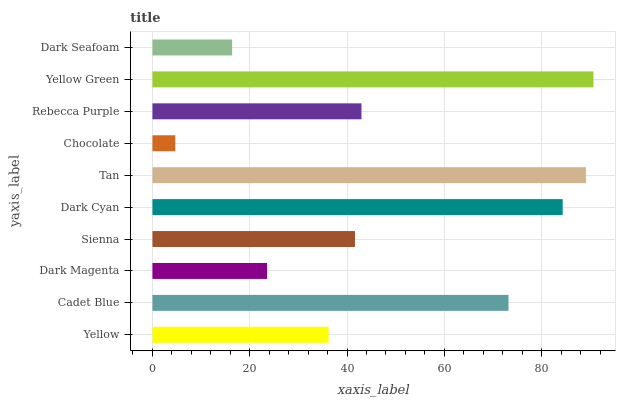Is Chocolate the minimum?
Answer yes or no. Yes. Is Yellow Green the maximum?
Answer yes or no. Yes. Is Cadet Blue the minimum?
Answer yes or no. No. Is Cadet Blue the maximum?
Answer yes or no. No. Is Cadet Blue greater than Yellow?
Answer yes or no. Yes. Is Yellow less than Cadet Blue?
Answer yes or no. Yes. Is Yellow greater than Cadet Blue?
Answer yes or no. No. Is Cadet Blue less than Yellow?
Answer yes or no. No. Is Rebecca Purple the high median?
Answer yes or no. Yes. Is Sienna the low median?
Answer yes or no. Yes. Is Yellow the high median?
Answer yes or no. No. Is Yellow the low median?
Answer yes or no. No. 